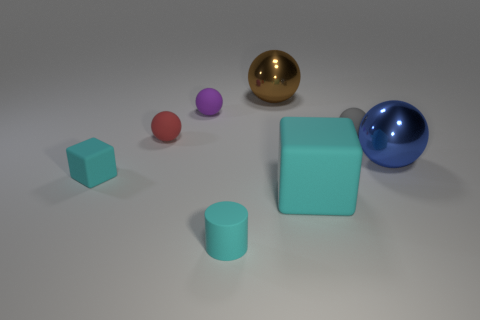Is the tiny matte cube the same color as the cylinder?
Make the answer very short. Yes. What is the size of the cylinder that is the same color as the small matte cube?
Keep it short and to the point. Small. Are there any large green shiny blocks?
Your answer should be compact. No. What shape is the small cyan object that is in front of the cyan cube on the left side of the large metal ball that is behind the small red ball?
Make the answer very short. Cylinder. How many red spheres are to the right of the large cyan cube?
Your answer should be very brief. 0. Do the block to the left of the small purple rubber object and the red object have the same material?
Your answer should be very brief. Yes. How many other objects are there of the same shape as the red thing?
Make the answer very short. 4. What number of large shiny spheres are on the left side of the large metal thing that is right of the sphere behind the tiny purple thing?
Offer a terse response. 1. There is a rubber block that is on the right side of the small cyan cylinder; what is its color?
Your answer should be compact. Cyan. There is a matte block that is to the right of the brown ball; is it the same color as the tiny matte cylinder?
Make the answer very short. Yes. 